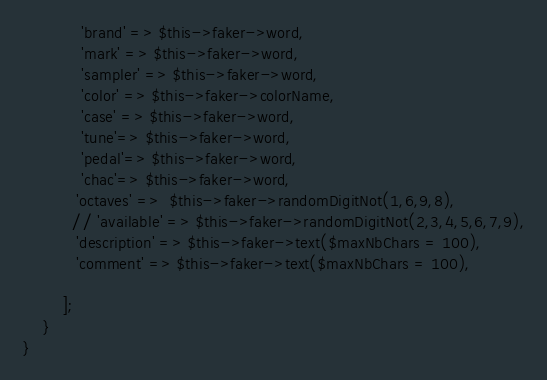Convert code to text. <code><loc_0><loc_0><loc_500><loc_500><_PHP_>            'brand' => $this->faker->word,
            'mark' => $this->faker->word,
            'sampler' => $this->faker->word,
            'color' => $this->faker->colorName,
            'case' => $this->faker->word,
            'tune'=> $this->faker->word,
            'pedal'=> $this->faker->word,
            'chac'=> $this->faker->word,
           'octaves' =>  $this->faker->randomDigitNot(1,6,9,8),
          // 'available' => $this->faker->randomDigitNot(2,3,4,5,6,7,9),
           'description' => $this->faker->text($maxNbChars = 100),
           'comment' => $this->faker->text($maxNbChars = 100),
           
        ];
    }
}
</code> 